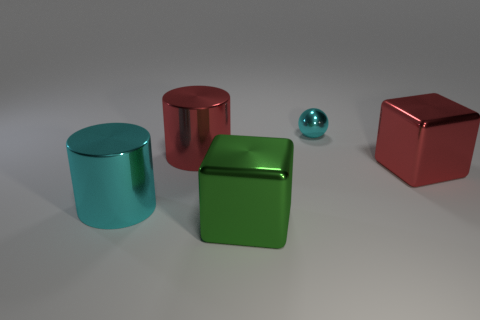Add 3 large yellow metal cylinders. How many objects exist? 8 Subtract all spheres. How many objects are left? 4 Add 1 cyan balls. How many cyan balls are left? 2 Add 2 gray shiny blocks. How many gray shiny blocks exist? 2 Subtract 0 purple balls. How many objects are left? 5 Subtract all cylinders. Subtract all big red shiny cylinders. How many objects are left? 2 